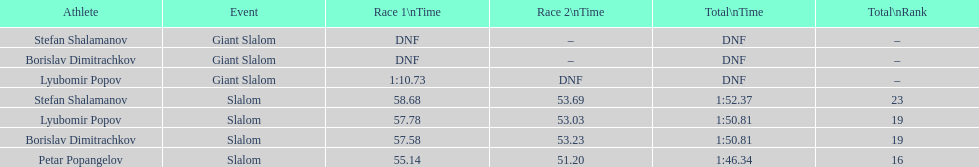Which athletes had consecutive times under 58 for both races? Lyubomir Popov, Borislav Dimitrachkov, Petar Popangelov. 